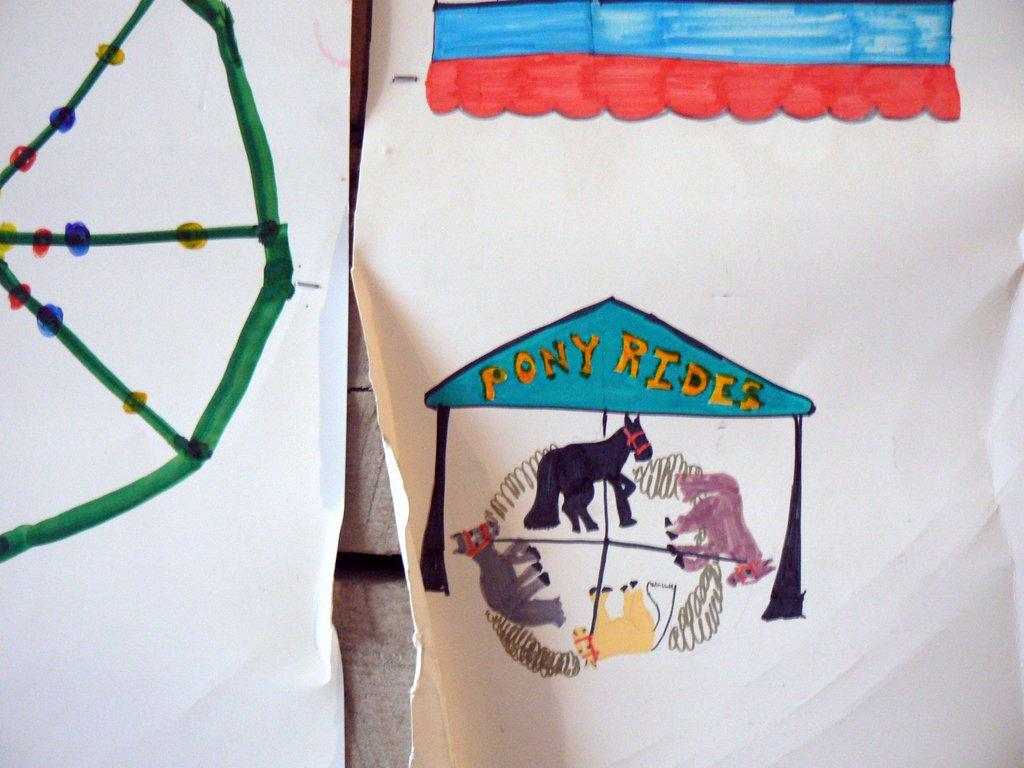What type of objects are present in the image? There are two white charts and a painting with green, red, blue, and yellow colors in the image. Can you describe the painting in more detail? The painting features animal paintings with different colors. What colors are used in the painting? The painting uses green, red, blue, and yellow colors. How many ducks are present in the image? There are no ducks present in the image. What type of pen is used to create the animal paintings in the image? There is no information about the type of pen used to create the animal paintings in the image. 